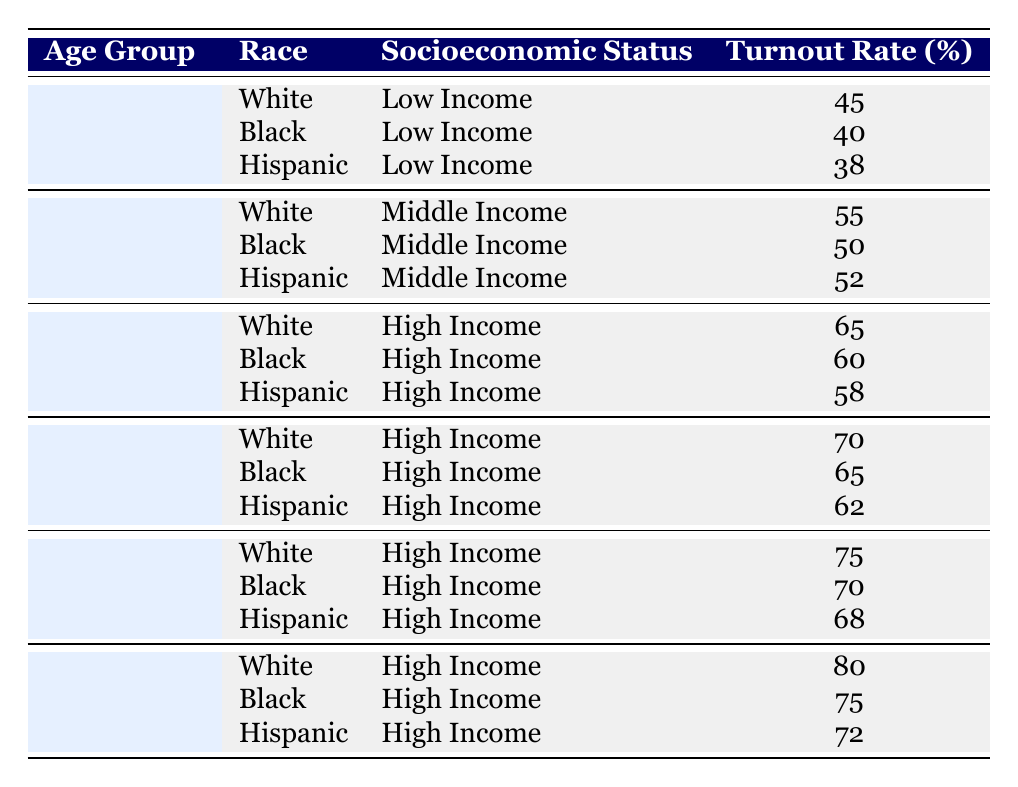What is the turnout rate for 18-24 year old Black individuals with low income? The table directly shows the turnout rate for this demographic alongside others in the same category. Specifically, it lists that for the age group of 18-24, Black individuals with low income have a turnout rate of 40%.
Answer: 40% What is the average turnout rate for Hispanic individuals across all age groups with high income? There are three data points for Hispanic individuals in the high-income category: 58%, 62%, and 68%. The average is calculated by summing these rates (58 + 62 + 68 = 188) and then dividing by 3 (188/3 = 62.67). Rounding gives approximately 63%.
Answer: 63% Is the turnout rate for 55-64 year old White individuals higher than that for 65 and above year old Black individuals? From the table, the turnout rate for 55-64 year old White individuals is 75%, while for 65 and above year old Black individuals, it is 75%. Since both values are equal, the statement is false.
Answer: No How many percentage points higher is the turnout rate for 45-54 year old White individuals compared to 18-24 year old Hispanic individuals? The turnout rate for 45-54 year old White individuals is 70%, and for 18-24 year old Hispanic individuals it is 38%. The difference is calculated by subtracting the two values (70 - 38 = 32). Thus, it is 32 percentage points higher.
Answer: 32 Do individuals aged 25-34 have a higher turnout rate if they are White or Black? The table shows that for the 25-34 age group, Whites have a turnout rate of 55% while Blacks have 50%. Comparing these two values, Whites have a higher turnout rate.
Answer: Yes What is the overall turnout rate average for all individuals aged 65 and above? The turnout rates for individuals aged 65 and above, according to the table, are 80% for Whites, 75% for Blacks, and 72% for Hispanics. To find the average, sum these rates (80 + 75 + 72 = 227) and divide by 3 (227/3 ≈ 75.67). Rounding gives approximately 76%.
Answer: 76 Which racial group had the lowest turnout rate in the 18-24 age category? In the 18-24 age category, the turnout rates listed are 45% for Whites, 40% for Blacks, and 38% for Hispanics. Among these, Hispanics have the lowest turnout rate.
Answer: Hispanics In which age group does the turnout rate for Black individuals exceed that of White individuals? Looking through the table, Black individuals have a turnout rate of 60% compared to 65% for White individuals in the 35-44 age group, but in the 45-54 age group, the rate is 65% for Black individuals compared to 70% for White individuals. Since neither group has an age group exceeding the other, the conclusion is that Black individuals do not exceed White in any age category.
Answer: No 